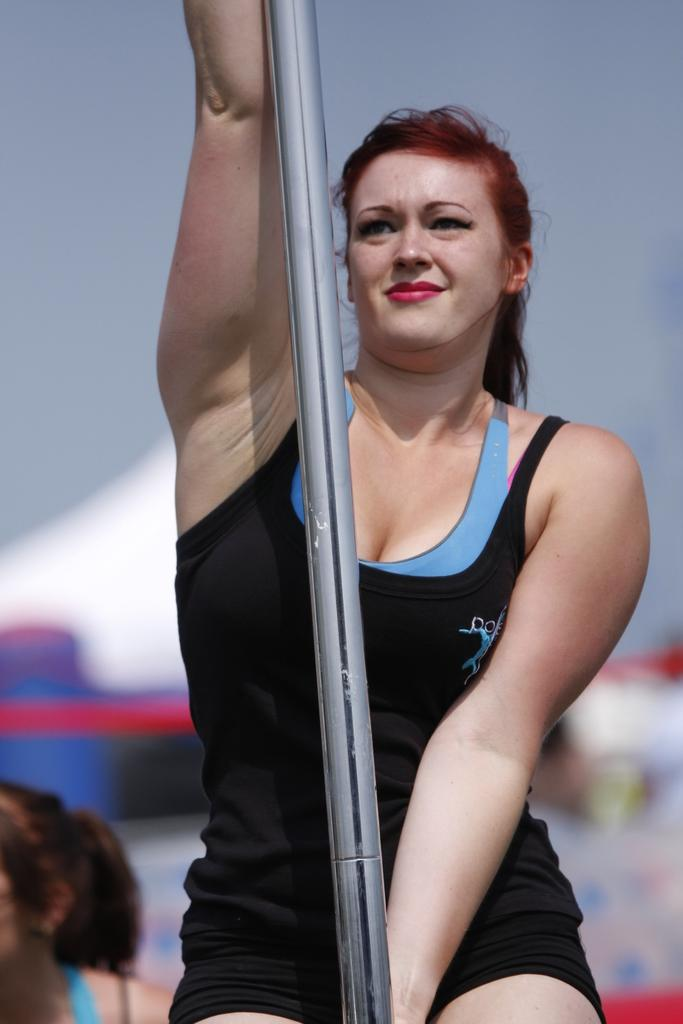Who is the main subject in the image? There is a woman in the image. What is the woman holding in the image? The woman is holding a pole. Can you describe the background of the image? The background of the image is blurry. What type of fowl can be seen flying in the background of the image? There is no fowl visible in the image, and the background is blurry. What kind of cracker is the woman holding in the image? The woman is holding a pole, not a cracker, in the image. 